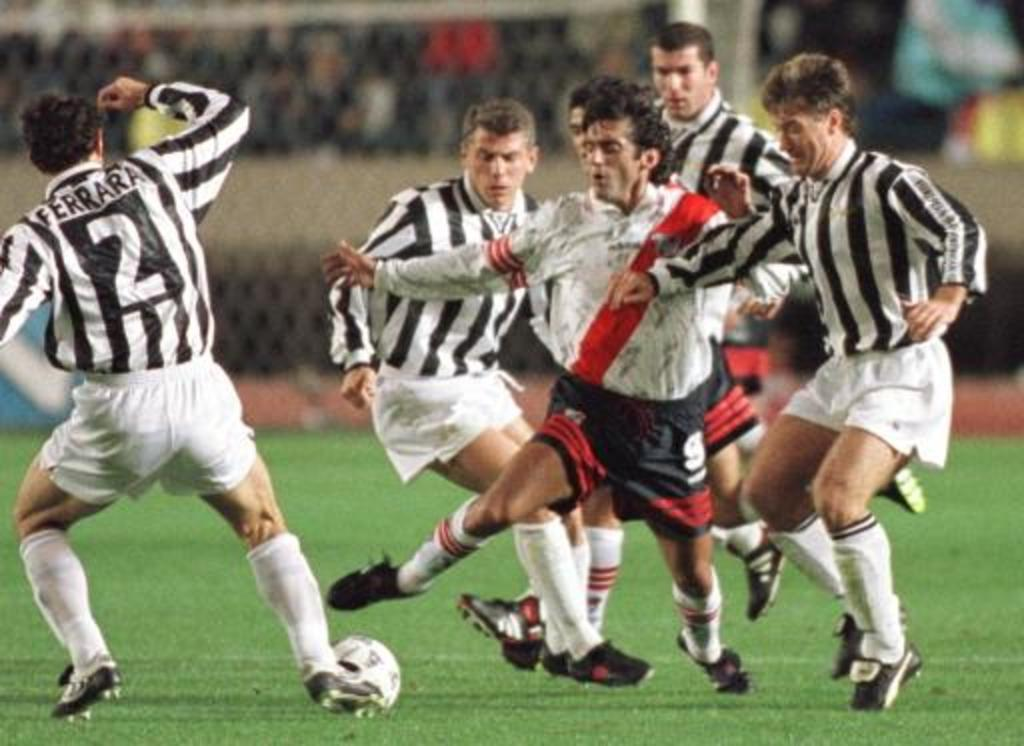<image>
Write a terse but informative summary of the picture. a few players in black and white including one with the number 2 